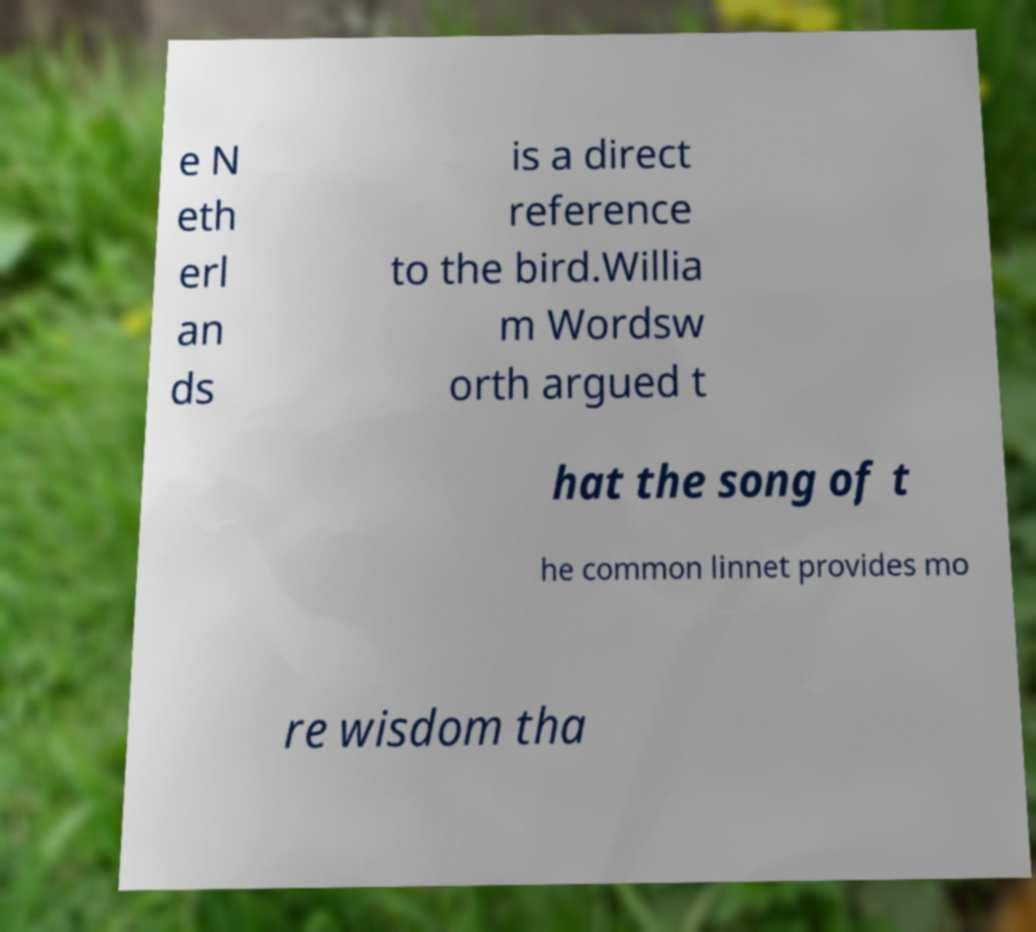What messages or text are displayed in this image? I need them in a readable, typed format. e N eth erl an ds is a direct reference to the bird.Willia m Wordsw orth argued t hat the song of t he common linnet provides mo re wisdom tha 